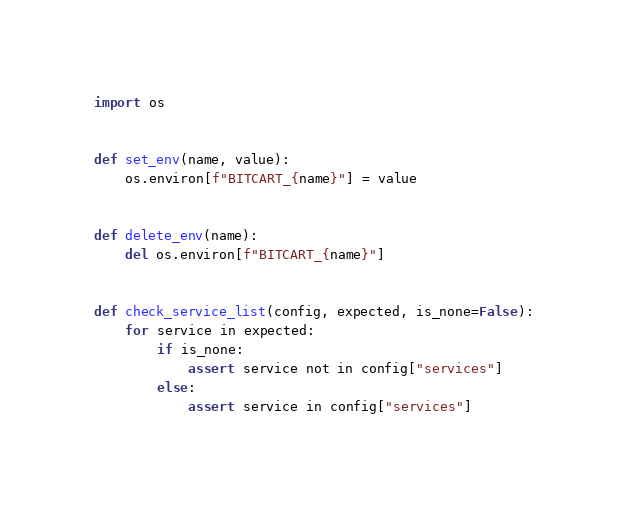<code> <loc_0><loc_0><loc_500><loc_500><_Python_>import os


def set_env(name, value):
    os.environ[f"BITCART_{name}"] = value


def delete_env(name):
    del os.environ[f"BITCART_{name}"]


def check_service_list(config, expected, is_none=False):
    for service in expected:
        if is_none:
            assert service not in config["services"]
        else:
            assert service in config["services"]
</code> 